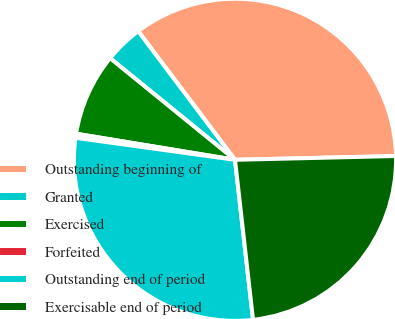<chart> <loc_0><loc_0><loc_500><loc_500><pie_chart><fcel>Outstanding beginning of<fcel>Granted<fcel>Exercised<fcel>Forfeited<fcel>Outstanding end of period<fcel>Exercisable end of period<nl><fcel>34.9%<fcel>3.86%<fcel>8.28%<fcel>0.41%<fcel>28.97%<fcel>23.59%<nl></chart> 